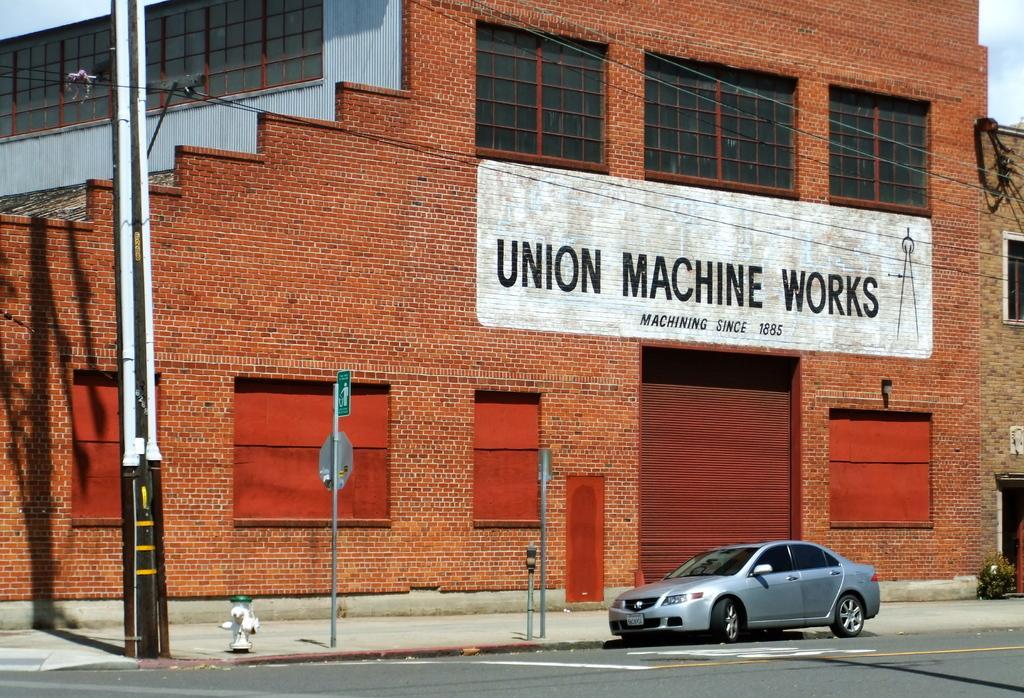Can you describe this image briefly? In the center of the image we can see the text on the wall. In the background of the image we can see a building, windows, shutter, wires, poles, boards, car, plant. At the bottom of the image we can see the road, fire hose and footpath. In the top right corner we can see the sky. 